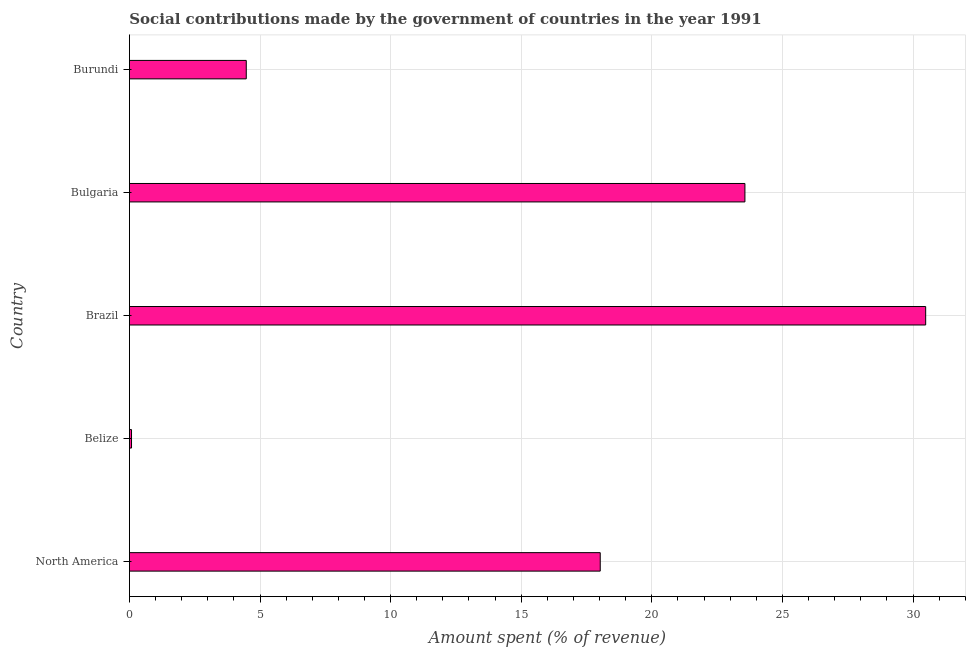Does the graph contain any zero values?
Provide a succinct answer. No. Does the graph contain grids?
Provide a short and direct response. Yes. What is the title of the graph?
Your answer should be very brief. Social contributions made by the government of countries in the year 1991. What is the label or title of the X-axis?
Offer a very short reply. Amount spent (% of revenue). What is the amount spent in making social contributions in Burundi?
Provide a succinct answer. 4.47. Across all countries, what is the maximum amount spent in making social contributions?
Keep it short and to the point. 30.48. Across all countries, what is the minimum amount spent in making social contributions?
Your response must be concise. 0.08. In which country was the amount spent in making social contributions minimum?
Provide a short and direct response. Belize. What is the sum of the amount spent in making social contributions?
Offer a very short reply. 76.63. What is the difference between the amount spent in making social contributions in Belize and Burundi?
Ensure brevity in your answer.  -4.39. What is the average amount spent in making social contributions per country?
Keep it short and to the point. 15.32. What is the median amount spent in making social contributions?
Make the answer very short. 18.02. In how many countries, is the amount spent in making social contributions greater than 12 %?
Ensure brevity in your answer.  3. What is the ratio of the amount spent in making social contributions in Bulgaria to that in North America?
Ensure brevity in your answer.  1.31. Is the amount spent in making social contributions in Belize less than that in Bulgaria?
Make the answer very short. Yes. What is the difference between the highest and the second highest amount spent in making social contributions?
Offer a terse response. 6.92. What is the difference between the highest and the lowest amount spent in making social contributions?
Give a very brief answer. 30.4. In how many countries, is the amount spent in making social contributions greater than the average amount spent in making social contributions taken over all countries?
Give a very brief answer. 3. Are all the bars in the graph horizontal?
Provide a short and direct response. Yes. How many countries are there in the graph?
Give a very brief answer. 5. What is the difference between two consecutive major ticks on the X-axis?
Your answer should be compact. 5. What is the Amount spent (% of revenue) in North America?
Keep it short and to the point. 18.02. What is the Amount spent (% of revenue) in Belize?
Your answer should be compact. 0.08. What is the Amount spent (% of revenue) in Brazil?
Ensure brevity in your answer.  30.48. What is the Amount spent (% of revenue) in Bulgaria?
Ensure brevity in your answer.  23.56. What is the Amount spent (% of revenue) in Burundi?
Your answer should be compact. 4.47. What is the difference between the Amount spent (% of revenue) in North America and Belize?
Offer a terse response. 17.94. What is the difference between the Amount spent (% of revenue) in North America and Brazil?
Offer a very short reply. -12.46. What is the difference between the Amount spent (% of revenue) in North America and Bulgaria?
Make the answer very short. -5.54. What is the difference between the Amount spent (% of revenue) in North America and Burundi?
Your answer should be compact. 13.55. What is the difference between the Amount spent (% of revenue) in Belize and Brazil?
Your response must be concise. -30.4. What is the difference between the Amount spent (% of revenue) in Belize and Bulgaria?
Ensure brevity in your answer.  -23.48. What is the difference between the Amount spent (% of revenue) in Belize and Burundi?
Offer a terse response. -4.39. What is the difference between the Amount spent (% of revenue) in Brazil and Bulgaria?
Offer a terse response. 6.92. What is the difference between the Amount spent (% of revenue) in Brazil and Burundi?
Your answer should be very brief. 26.01. What is the difference between the Amount spent (% of revenue) in Bulgaria and Burundi?
Your answer should be compact. 19.09. What is the ratio of the Amount spent (% of revenue) in North America to that in Belize?
Your response must be concise. 222.1. What is the ratio of the Amount spent (% of revenue) in North America to that in Brazil?
Provide a short and direct response. 0.59. What is the ratio of the Amount spent (% of revenue) in North America to that in Bulgaria?
Ensure brevity in your answer.  0.77. What is the ratio of the Amount spent (% of revenue) in North America to that in Burundi?
Give a very brief answer. 4.03. What is the ratio of the Amount spent (% of revenue) in Belize to that in Brazil?
Offer a terse response. 0. What is the ratio of the Amount spent (% of revenue) in Belize to that in Bulgaria?
Your response must be concise. 0. What is the ratio of the Amount spent (% of revenue) in Belize to that in Burundi?
Keep it short and to the point. 0.02. What is the ratio of the Amount spent (% of revenue) in Brazil to that in Bulgaria?
Offer a terse response. 1.29. What is the ratio of the Amount spent (% of revenue) in Brazil to that in Burundi?
Your answer should be very brief. 6.81. What is the ratio of the Amount spent (% of revenue) in Bulgaria to that in Burundi?
Your answer should be very brief. 5.27. 